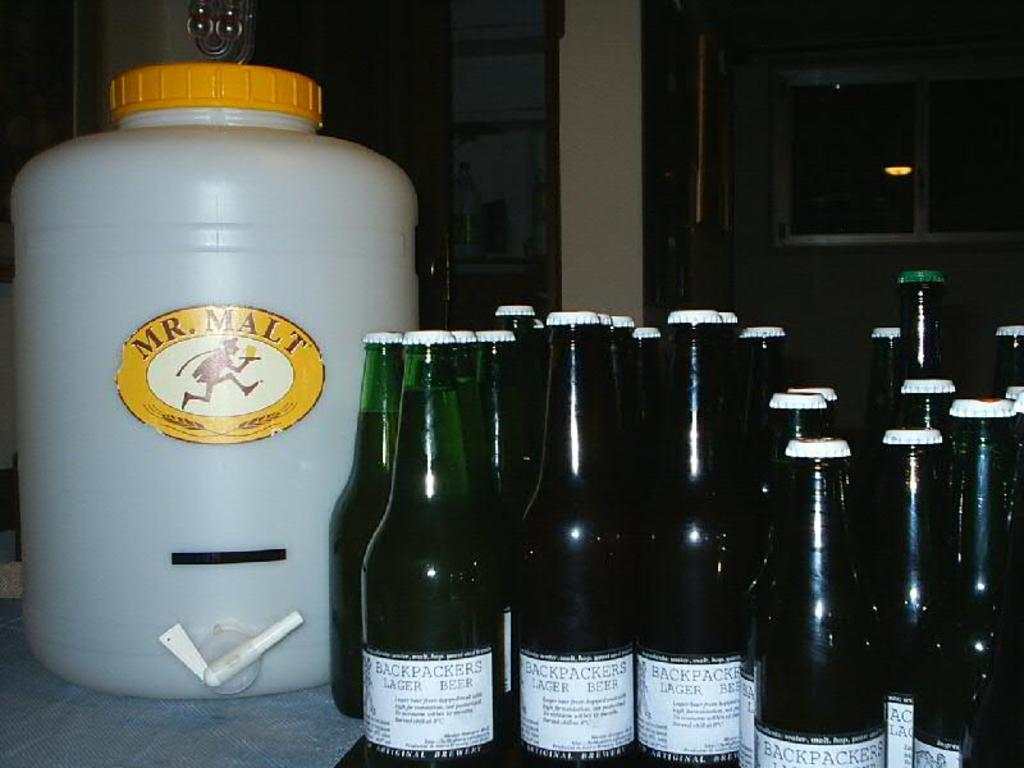<image>
Create a compact narrative representing the image presented. Beer bottles of Back Packers with larger can of Mr. Malt branded 